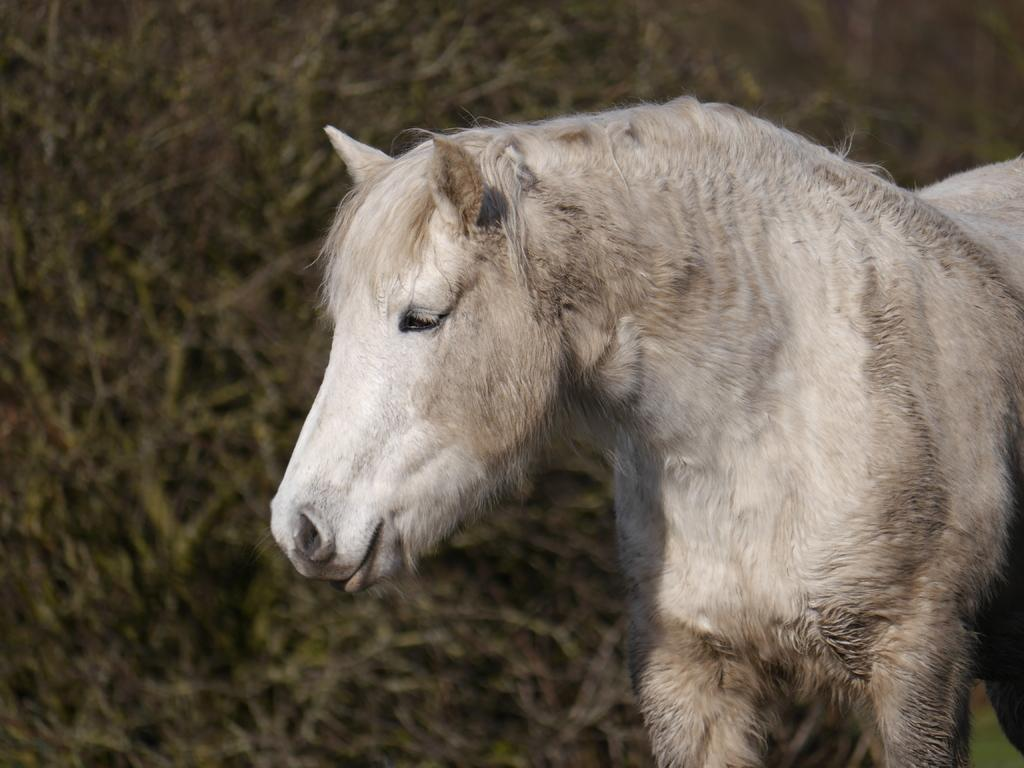What type of creature is present in the image? There is an animal in the image. What color is the animal? The animal is white in color. What does the animal resemble? The animal resembles a horse. What type of equipment does the fireman use in the image? There is no fireman present in the image; it features an animal that resembles a horse. What type of yard maintenance is being performed in the image? There is no yard or maintenance activity depicted in the image; it features an animal that resembles a horse. 